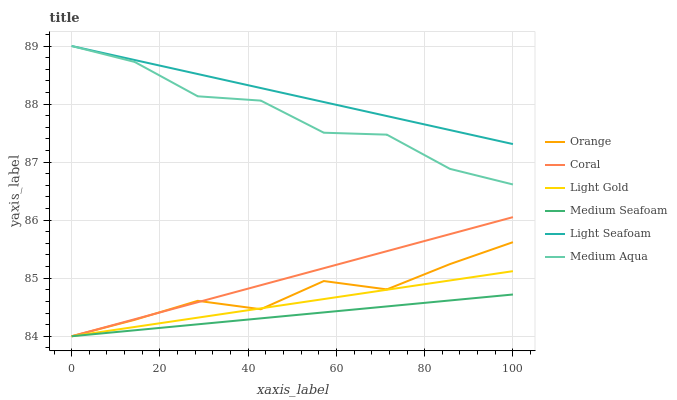Does Medium Aqua have the minimum area under the curve?
Answer yes or no. No. Does Medium Aqua have the maximum area under the curve?
Answer yes or no. No. Is Orange the smoothest?
Answer yes or no. No. Is Orange the roughest?
Answer yes or no. No. Does Medium Aqua have the lowest value?
Answer yes or no. No. Does Orange have the highest value?
Answer yes or no. No. Is Coral less than Medium Aqua?
Answer yes or no. Yes. Is Light Seafoam greater than Orange?
Answer yes or no. Yes. Does Coral intersect Medium Aqua?
Answer yes or no. No. 